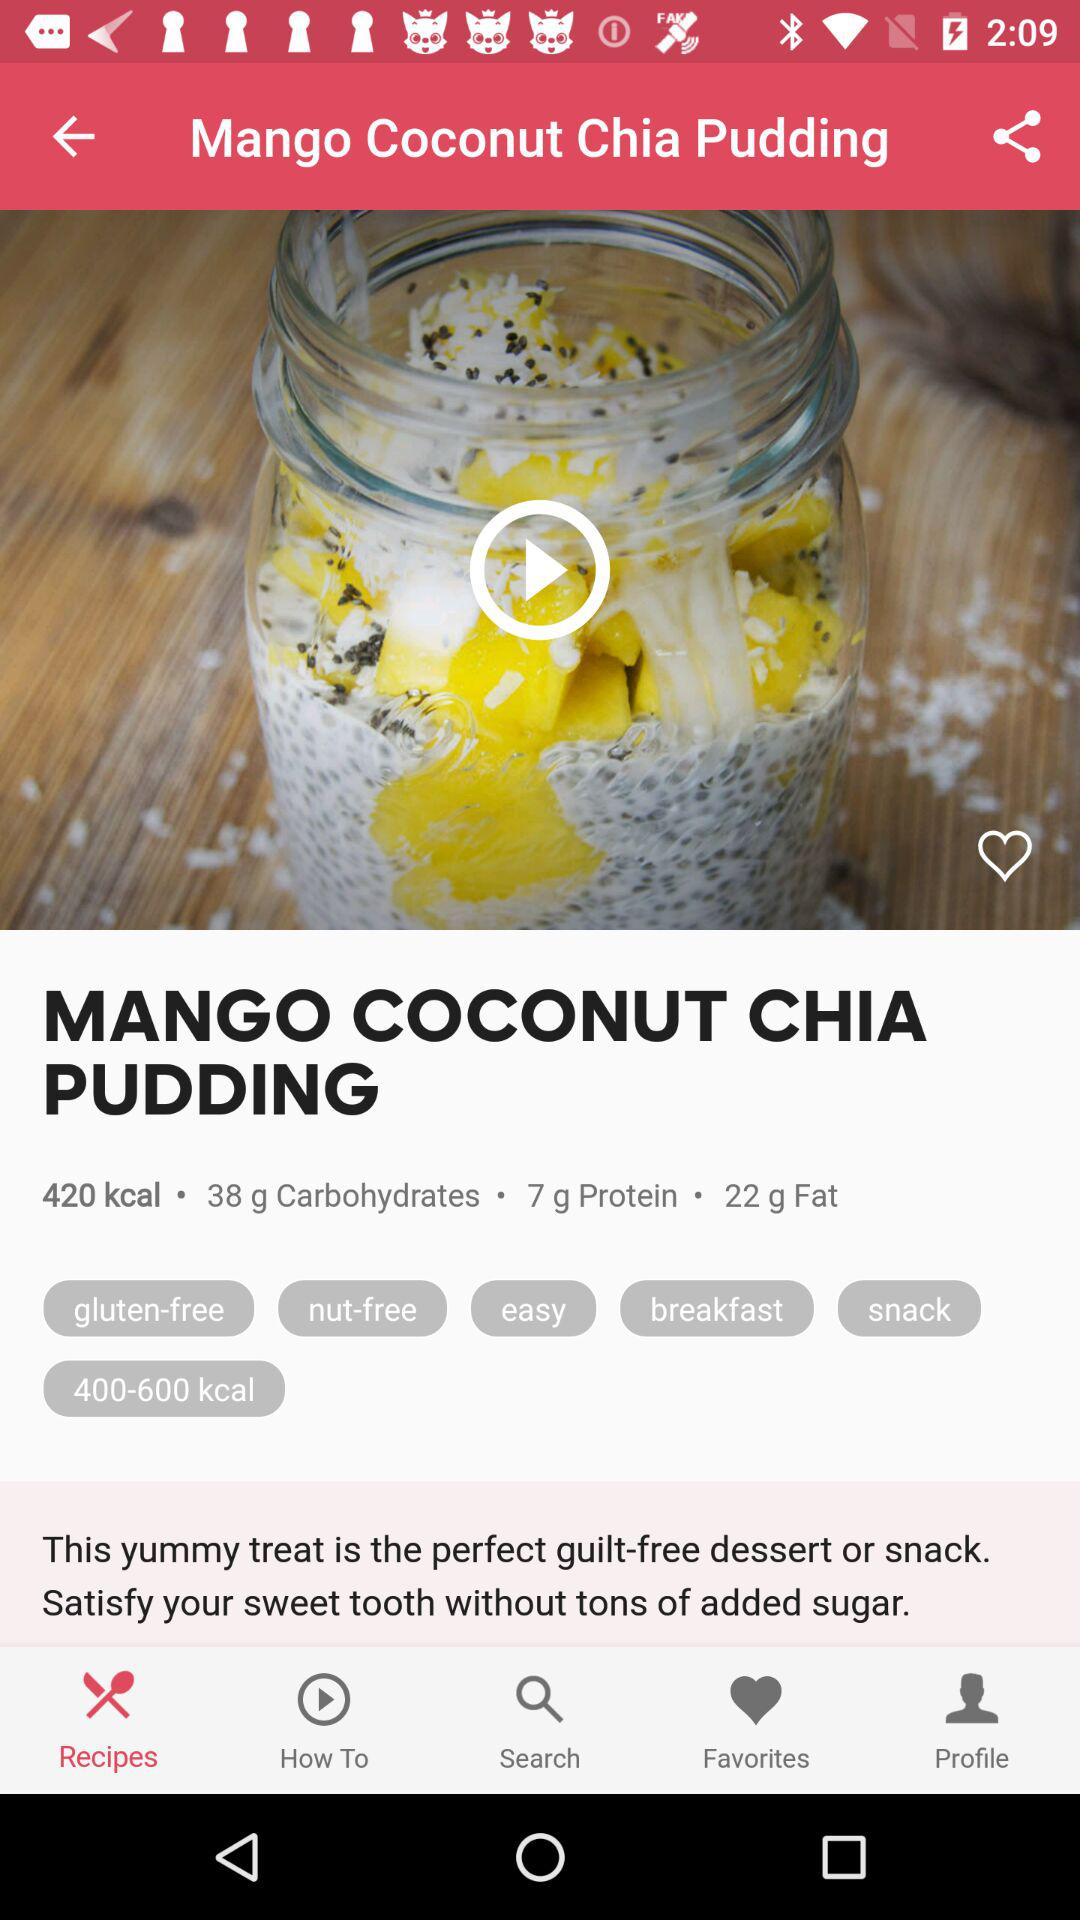What makes this Mango Coconut Chia Pudding a guilt-free dessert option? This delightful pudding is considered guilt-free because it offers the sweetness and creamy texture of a dessert without a heavy amount of added sugars. The ingredients are wholesome, and it's a treat that fits into a balanced, health-conscious diet. And at 420 kcal per serving, it aligns with the energy needs for a meal or a substantial snack. 